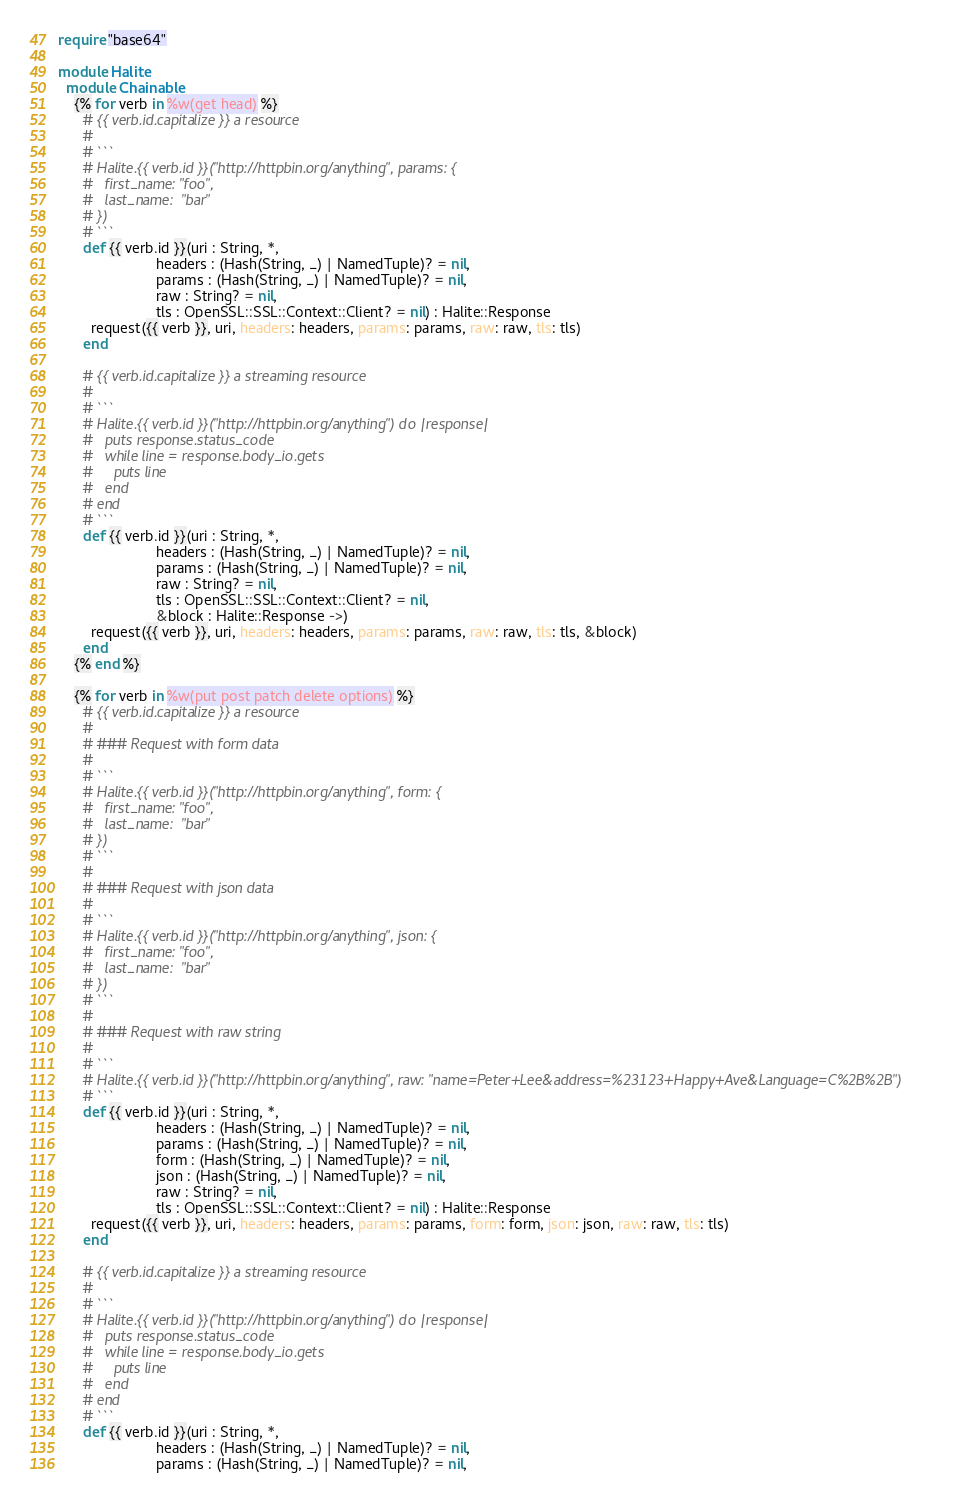Convert code to text. <code><loc_0><loc_0><loc_500><loc_500><_Crystal_>require "base64"

module Halite
  module Chainable
    {% for verb in %w(get head) %}
      # {{ verb.id.capitalize }} a resource
      #
      # ```
      # Halite.{{ verb.id }}("http://httpbin.org/anything", params: {
      #   first_name: "foo",
      #   last_name:  "bar"
      # })
      # ```
      def {{ verb.id }}(uri : String, *,
                        headers : (Hash(String, _) | NamedTuple)? = nil,
                        params : (Hash(String, _) | NamedTuple)? = nil,
                        raw : String? = nil,
                        tls : OpenSSL::SSL::Context::Client? = nil) : Halite::Response
        request({{ verb }}, uri, headers: headers, params: params, raw: raw, tls: tls)
      end

      # {{ verb.id.capitalize }} a streaming resource
      #
      # ```
      # Halite.{{ verb.id }}("http://httpbin.org/anything") do |response|
      #   puts response.status_code
      #   while line = response.body_io.gets
      #     puts line
      #   end
      # end
      # ```
      def {{ verb.id }}(uri : String, *,
                        headers : (Hash(String, _) | NamedTuple)? = nil,
                        params : (Hash(String, _) | NamedTuple)? = nil,
                        raw : String? = nil,
                        tls : OpenSSL::SSL::Context::Client? = nil,
                        &block : Halite::Response ->)
        request({{ verb }}, uri, headers: headers, params: params, raw: raw, tls: tls, &block)
      end
    {% end %}

    {% for verb in %w(put post patch delete options) %}
      # {{ verb.id.capitalize }} a resource
      #
      # ### Request with form data
      #
      # ```
      # Halite.{{ verb.id }}("http://httpbin.org/anything", form: {
      #   first_name: "foo",
      #   last_name:  "bar"
      # })
      # ```
      #
      # ### Request with json data
      #
      # ```
      # Halite.{{ verb.id }}("http://httpbin.org/anything", json: {
      #   first_name: "foo",
      #   last_name:  "bar"
      # })
      # ```
      #
      # ### Request with raw string
      #
      # ```
      # Halite.{{ verb.id }}("http://httpbin.org/anything", raw: "name=Peter+Lee&address=%23123+Happy+Ave&Language=C%2B%2B")
      # ```
      def {{ verb.id }}(uri : String, *,
                        headers : (Hash(String, _) | NamedTuple)? = nil,
                        params : (Hash(String, _) | NamedTuple)? = nil,
                        form : (Hash(String, _) | NamedTuple)? = nil,
                        json : (Hash(String, _) | NamedTuple)? = nil,
                        raw : String? = nil,
                        tls : OpenSSL::SSL::Context::Client? = nil) : Halite::Response
        request({{ verb }}, uri, headers: headers, params: params, form: form, json: json, raw: raw, tls: tls)
      end

      # {{ verb.id.capitalize }} a streaming resource
      #
      # ```
      # Halite.{{ verb.id }}("http://httpbin.org/anything") do |response|
      #   puts response.status_code
      #   while line = response.body_io.gets
      #     puts line
      #   end
      # end
      # ```
      def {{ verb.id }}(uri : String, *,
                        headers : (Hash(String, _) | NamedTuple)? = nil,
                        params : (Hash(String, _) | NamedTuple)? = nil,</code> 